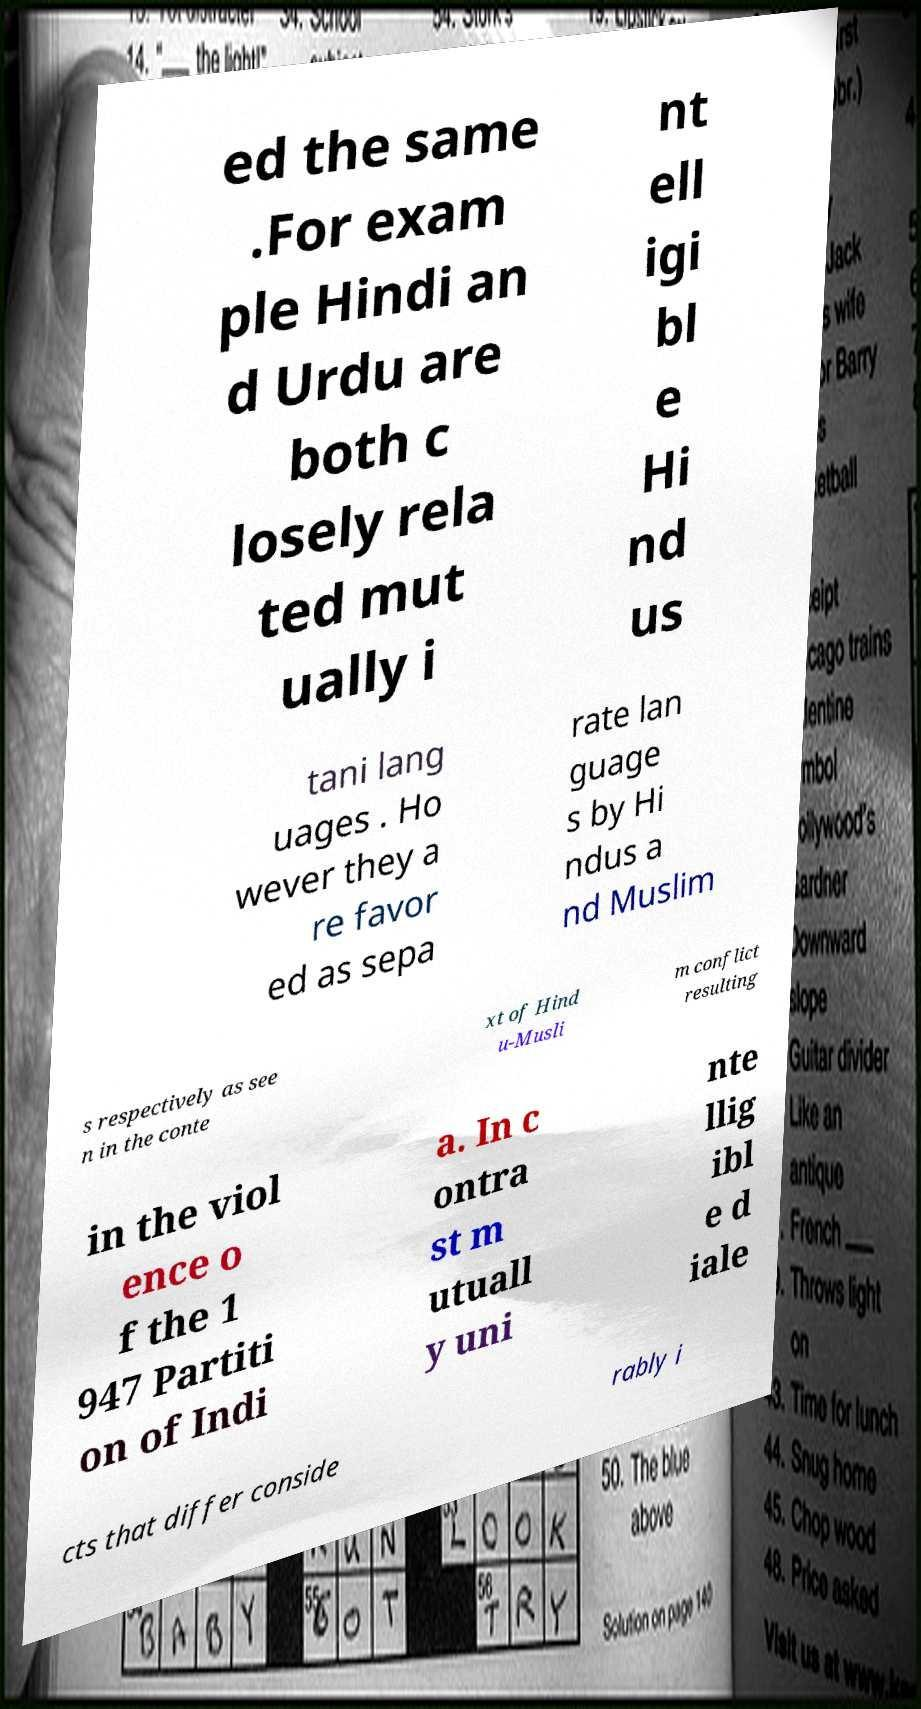Can you read and provide the text displayed in the image?This photo seems to have some interesting text. Can you extract and type it out for me? ed the same .For exam ple Hindi an d Urdu are both c losely rela ted mut ually i nt ell igi bl e Hi nd us tani lang uages . Ho wever they a re favor ed as sepa rate lan guage s by Hi ndus a nd Muslim s respectively as see n in the conte xt of Hind u-Musli m conflict resulting in the viol ence o f the 1 947 Partiti on of Indi a. In c ontra st m utuall y uni nte llig ibl e d iale cts that differ conside rably i 